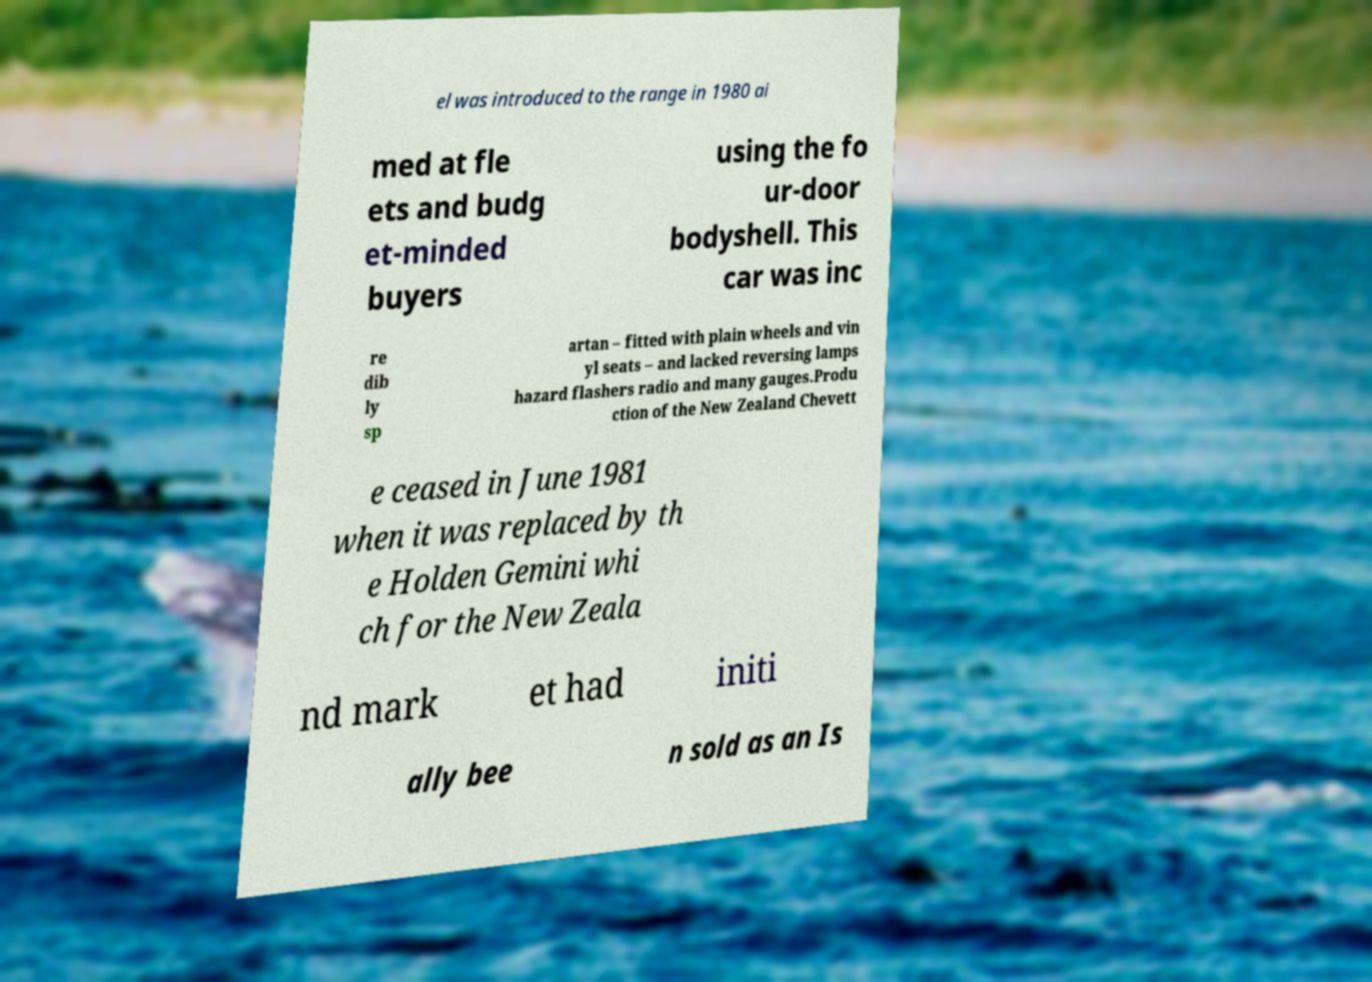Can you read and provide the text displayed in the image?This photo seems to have some interesting text. Can you extract and type it out for me? el was introduced to the range in 1980 ai med at fle ets and budg et-minded buyers using the fo ur-door bodyshell. This car was inc re dib ly sp artan – fitted with plain wheels and vin yl seats – and lacked reversing lamps hazard flashers radio and many gauges.Produ ction of the New Zealand Chevett e ceased in June 1981 when it was replaced by th e Holden Gemini whi ch for the New Zeala nd mark et had initi ally bee n sold as an Is 